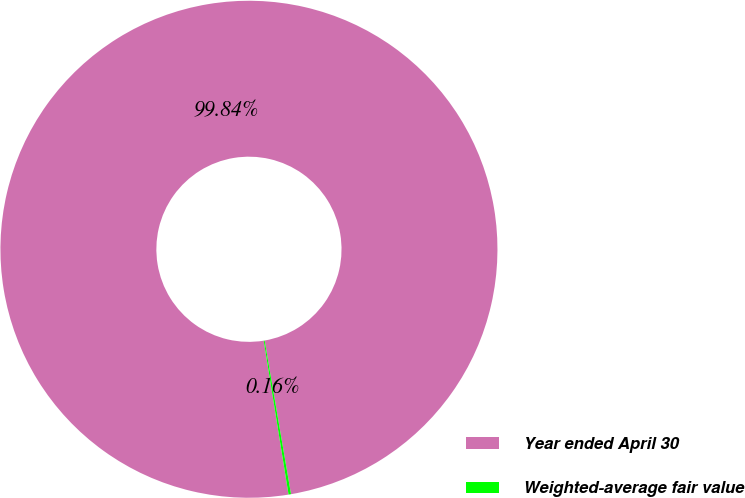Convert chart. <chart><loc_0><loc_0><loc_500><loc_500><pie_chart><fcel>Year ended April 30<fcel>Weighted-average fair value<nl><fcel>99.84%<fcel>0.16%<nl></chart> 